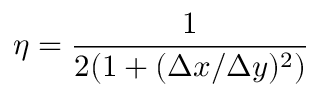Convert formula to latex. <formula><loc_0><loc_0><loc_500><loc_500>\eta = \frac { 1 } { 2 ( 1 + ( \Delta x / \Delta y ) ^ { 2 } ) }</formula> 